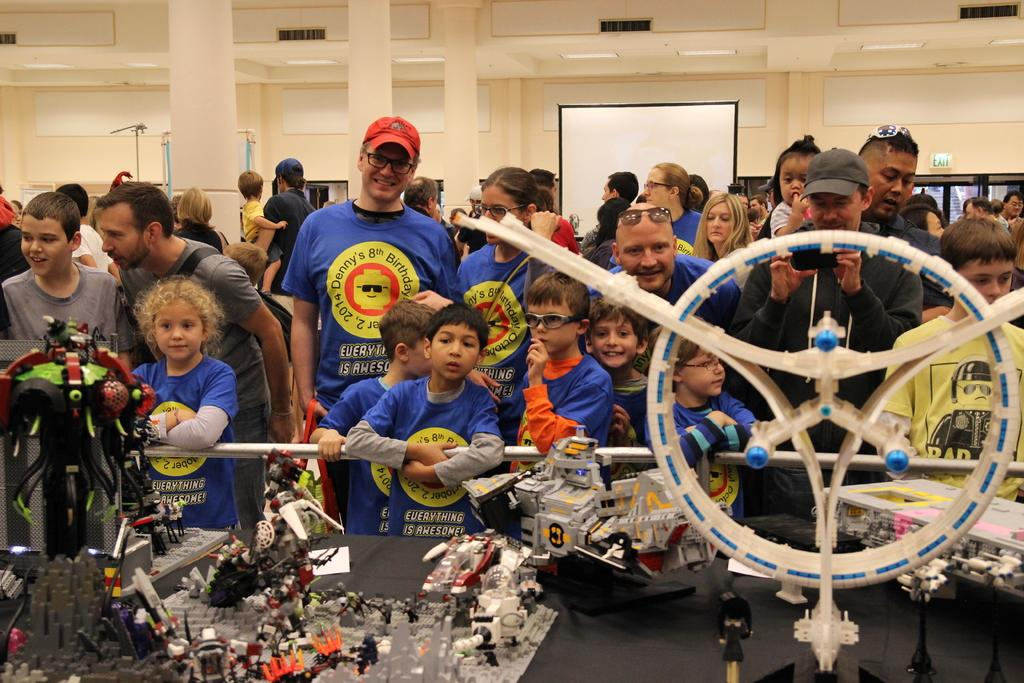What are the people in the image doing? The people in the image are standing in front of a table. What can be seen on the table? There are objects on the table. What is visible behind the table? There is a board visible behind the table, and there are windows in the wall behind the table. Can you see a ball being thrown in the image? There is no ball or any indication of a ball being thrown in the image. 